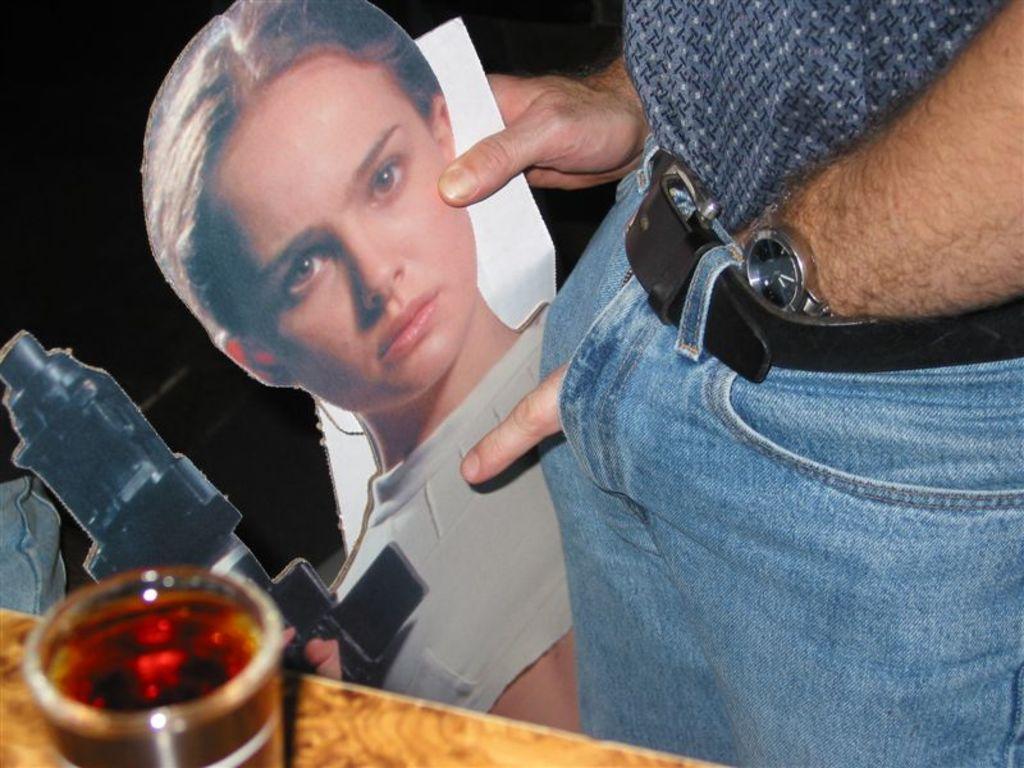Can you describe this image briefly? In this image there is some person holding a photograph of a man holding a gun. Image also consists of a glass of liquid on the surface. 